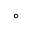Convert formula to latex. <formula><loc_0><loc_0><loc_500><loc_500>^ { \circ }</formula> 